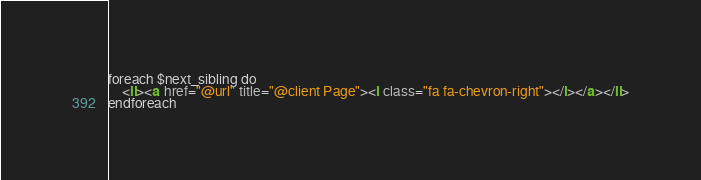Convert code to text. <code><loc_0><loc_0><loc_500><loc_500><_HTML_>foreach $next_sibling do
	<li><a href="@url" title="@client Page"><i class="fa fa-chevron-right"></i></a></li>
endforeach
</code> 